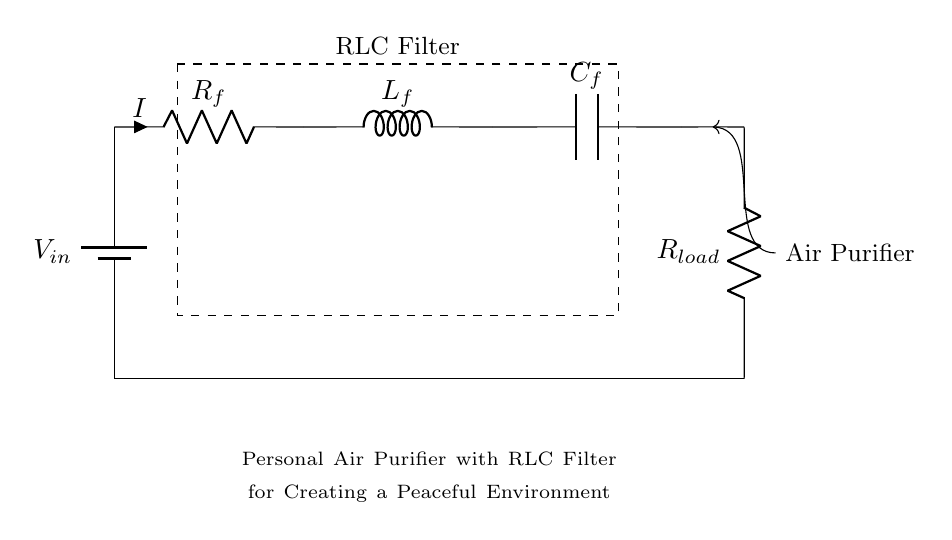What is the output load resistance? The output load resistance is represented by R load on the circuit diagram located at the bottom right corner of the RLC filter. Its value can be identified per the circuit labeling.
Answer: R load What are the types of components in this circuit? The components in the circuit include a resistor, an inductor, and a capacitor, which are represented as R, L, and C, respectively. They are all part of the RLC filter section, indicating the configuration of passive components used.
Answer: Resistor, Inductor, Capacitor What is the purpose of the RLC filter in this circuit? The RLC filter's purpose is to allow certain frequencies to pass while attenuating others. In the context of an air purifier, the filter helps create a peaceful environment by reducing undesirable noise frequency.
Answer: Noise filtering How does the total impedance of the circuit change with component values? The total impedance in an RLC circuit is affected by the resistance (R), inductance (L), and capacitance (C) values. As values change, the impedances will shift the resonant frequency, changing the filtering effect of the circuit, which can affect the air purifier's performance.
Answer: Impedance changes with R, L, C values What happens if the capacitor value increases? Increasing the capacitor value will lower the cutoff frequency of the filter, which will allow lower frequencies to pass through while blocking higher frequencies. This change can enhance how the air purifier handles certain noise frequencies that may disrupt a peaceful environment.
Answer: Lower frequency cutoff What is the input voltage supply for this circuit? The input voltage supply is indicated by V in, which is the voltage provided to the circuit to power it. It is located at the top left corner of the circuit diagram.
Answer: V in 